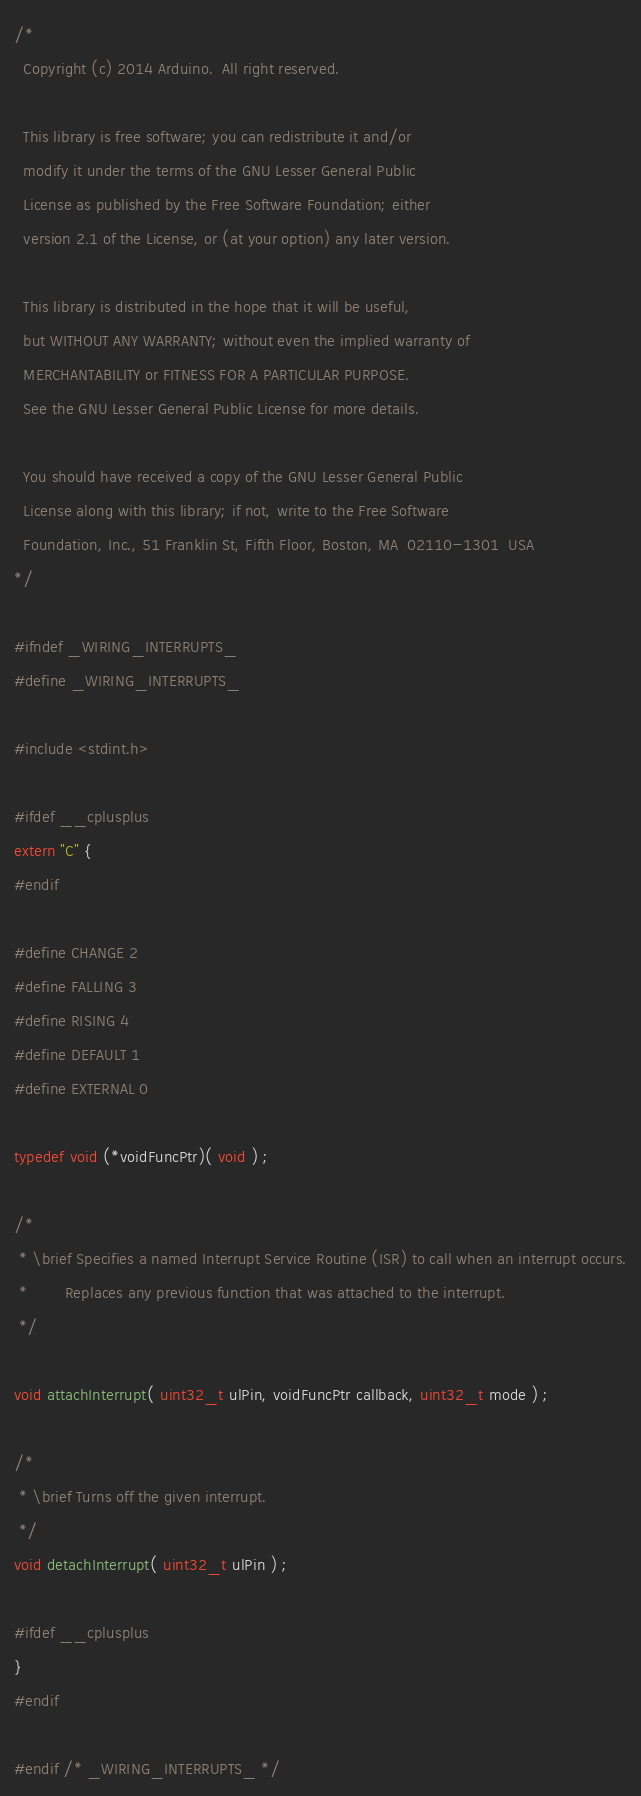Convert code to text. <code><loc_0><loc_0><loc_500><loc_500><_C_>/*
  Copyright (c) 2014 Arduino.  All right reserved.

  This library is free software; you can redistribute it and/or
  modify it under the terms of the GNU Lesser General Public
  License as published by the Free Software Foundation; either
  version 2.1 of the License, or (at your option) any later version.

  This library is distributed in the hope that it will be useful,
  but WITHOUT ANY WARRANTY; without even the implied warranty of
  MERCHANTABILITY or FITNESS FOR A PARTICULAR PURPOSE.
  See the GNU Lesser General Public License for more details.

  You should have received a copy of the GNU Lesser General Public
  License along with this library; if not, write to the Free Software
  Foundation, Inc., 51 Franklin St, Fifth Floor, Boston, MA  02110-1301  USA
*/

#ifndef _WIRING_INTERRUPTS_
#define _WIRING_INTERRUPTS_

#include <stdint.h>

#ifdef __cplusplus
extern "C" {
#endif

#define CHANGE 2
#define FALLING 3
#define RISING 4
#define DEFAULT 1
#define EXTERNAL 0

typedef void (*voidFuncPtr)( void ) ;

/*
 * \brief Specifies a named Interrupt Service Routine (ISR) to call when an interrupt occurs.
 *        Replaces any previous function that was attached to the interrupt.
 */

void attachInterrupt( uint32_t ulPin, voidFuncPtr callback, uint32_t mode ) ;

/*
 * \brief Turns off the given interrupt.
 */
void detachInterrupt( uint32_t ulPin ) ;

#ifdef __cplusplus
}
#endif

#endif /* _WIRING_INTERRUPTS_ */
</code> 